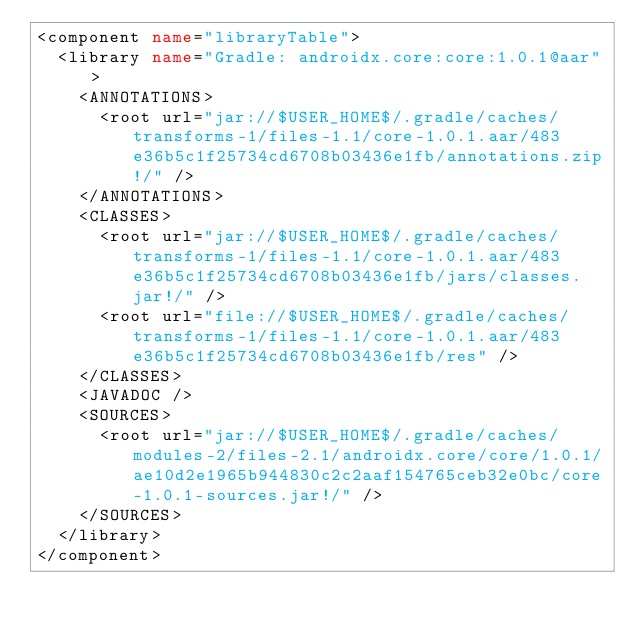<code> <loc_0><loc_0><loc_500><loc_500><_XML_><component name="libraryTable">
  <library name="Gradle: androidx.core:core:1.0.1@aar">
    <ANNOTATIONS>
      <root url="jar://$USER_HOME$/.gradle/caches/transforms-1/files-1.1/core-1.0.1.aar/483e36b5c1f25734cd6708b03436e1fb/annotations.zip!/" />
    </ANNOTATIONS>
    <CLASSES>
      <root url="jar://$USER_HOME$/.gradle/caches/transforms-1/files-1.1/core-1.0.1.aar/483e36b5c1f25734cd6708b03436e1fb/jars/classes.jar!/" />
      <root url="file://$USER_HOME$/.gradle/caches/transforms-1/files-1.1/core-1.0.1.aar/483e36b5c1f25734cd6708b03436e1fb/res" />
    </CLASSES>
    <JAVADOC />
    <SOURCES>
      <root url="jar://$USER_HOME$/.gradle/caches/modules-2/files-2.1/androidx.core/core/1.0.1/ae10d2e1965b944830c2c2aaf154765ceb32e0bc/core-1.0.1-sources.jar!/" />
    </SOURCES>
  </library>
</component></code> 